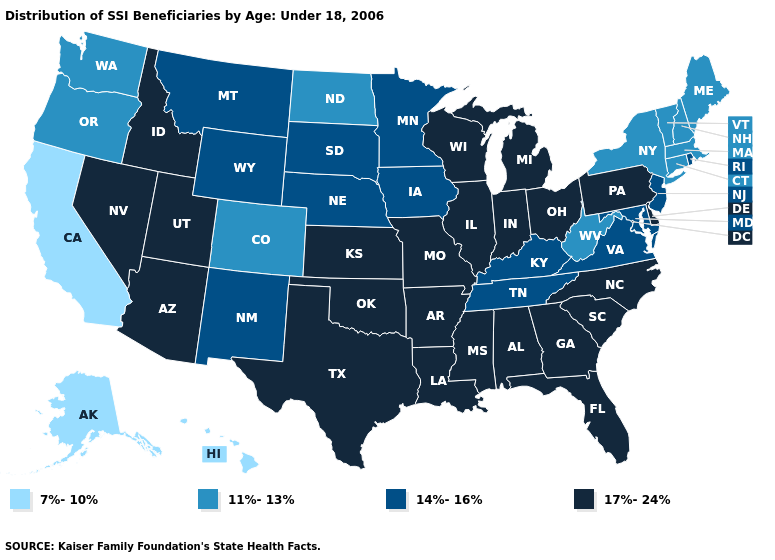Which states have the lowest value in the Northeast?
Give a very brief answer. Connecticut, Maine, Massachusetts, New Hampshire, New York, Vermont. What is the value of Washington?
Give a very brief answer. 11%-13%. Does Idaho have the same value as Pennsylvania?
Give a very brief answer. Yes. Does Minnesota have the same value as Virginia?
Be succinct. Yes. Does the first symbol in the legend represent the smallest category?
Write a very short answer. Yes. Does Pennsylvania have the highest value in the Northeast?
Quick response, please. Yes. What is the value of West Virginia?
Be succinct. 11%-13%. Is the legend a continuous bar?
Answer briefly. No. Does Louisiana have the highest value in the USA?
Give a very brief answer. Yes. Among the states that border Ohio , does Kentucky have the lowest value?
Be succinct. No. What is the value of Rhode Island?
Answer briefly. 14%-16%. What is the lowest value in the South?
Answer briefly. 11%-13%. Does Tennessee have the highest value in the USA?
Keep it brief. No. 